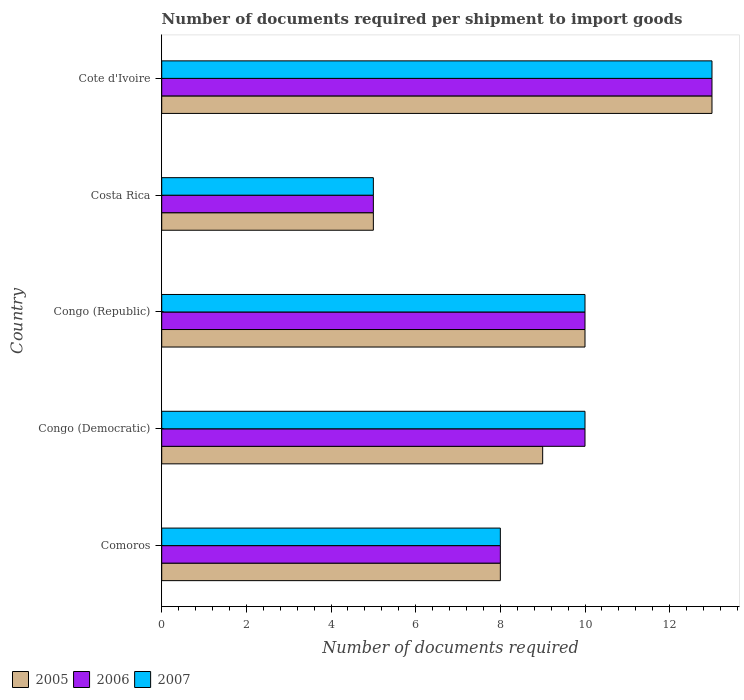How many different coloured bars are there?
Make the answer very short. 3. Are the number of bars on each tick of the Y-axis equal?
Make the answer very short. Yes. What is the label of the 4th group of bars from the top?
Give a very brief answer. Congo (Democratic). In how many cases, is the number of bars for a given country not equal to the number of legend labels?
Provide a short and direct response. 0. What is the number of documents required per shipment to import goods in 2006 in Costa Rica?
Ensure brevity in your answer.  5. Across all countries, what is the maximum number of documents required per shipment to import goods in 2006?
Your answer should be very brief. 13. In which country was the number of documents required per shipment to import goods in 2005 maximum?
Your answer should be very brief. Cote d'Ivoire. What is the total number of documents required per shipment to import goods in 2007 in the graph?
Give a very brief answer. 46. What is the difference between the number of documents required per shipment to import goods in 2006 in Comoros and the number of documents required per shipment to import goods in 2005 in Costa Rica?
Make the answer very short. 3. What is the difference between the number of documents required per shipment to import goods in 2005 and number of documents required per shipment to import goods in 2006 in Costa Rica?
Provide a short and direct response. 0. In how many countries, is the number of documents required per shipment to import goods in 2005 greater than 5.6 ?
Your answer should be very brief. 4. What is the ratio of the number of documents required per shipment to import goods in 2007 in Congo (Republic) to that in Cote d'Ivoire?
Your response must be concise. 0.77. Is the difference between the number of documents required per shipment to import goods in 2005 in Costa Rica and Cote d'Ivoire greater than the difference between the number of documents required per shipment to import goods in 2006 in Costa Rica and Cote d'Ivoire?
Keep it short and to the point. No. What is the difference between the highest and the second highest number of documents required per shipment to import goods in 2005?
Your answer should be compact. 3. What does the 1st bar from the top in Congo (Republic) represents?
Give a very brief answer. 2007. What does the 1st bar from the bottom in Congo (Republic) represents?
Keep it short and to the point. 2005. How many bars are there?
Offer a terse response. 15. Are all the bars in the graph horizontal?
Your answer should be very brief. Yes. How many countries are there in the graph?
Your answer should be compact. 5. What is the difference between two consecutive major ticks on the X-axis?
Offer a terse response. 2. Are the values on the major ticks of X-axis written in scientific E-notation?
Make the answer very short. No. Where does the legend appear in the graph?
Ensure brevity in your answer.  Bottom left. What is the title of the graph?
Ensure brevity in your answer.  Number of documents required per shipment to import goods. Does "2005" appear as one of the legend labels in the graph?
Your response must be concise. Yes. What is the label or title of the X-axis?
Provide a succinct answer. Number of documents required. What is the label or title of the Y-axis?
Provide a succinct answer. Country. What is the Number of documents required of 2006 in Comoros?
Your response must be concise. 8. What is the Number of documents required in 2005 in Congo (Democratic)?
Keep it short and to the point. 9. What is the Number of documents required in 2006 in Congo (Democratic)?
Make the answer very short. 10. What is the Number of documents required in 2005 in Congo (Republic)?
Make the answer very short. 10. What is the Number of documents required of 2006 in Congo (Republic)?
Provide a short and direct response. 10. What is the Number of documents required of 2005 in Costa Rica?
Offer a very short reply. 5. What is the Number of documents required of 2006 in Costa Rica?
Your response must be concise. 5. What is the Number of documents required in 2007 in Costa Rica?
Offer a very short reply. 5. Across all countries, what is the maximum Number of documents required in 2006?
Your response must be concise. 13. Across all countries, what is the maximum Number of documents required in 2007?
Your answer should be compact. 13. Across all countries, what is the minimum Number of documents required of 2005?
Your answer should be very brief. 5. Across all countries, what is the minimum Number of documents required of 2007?
Your response must be concise. 5. What is the total Number of documents required of 2005 in the graph?
Provide a short and direct response. 45. What is the total Number of documents required of 2006 in the graph?
Provide a short and direct response. 46. What is the difference between the Number of documents required in 2005 in Comoros and that in Congo (Democratic)?
Your answer should be very brief. -1. What is the difference between the Number of documents required in 2006 in Comoros and that in Congo (Democratic)?
Ensure brevity in your answer.  -2. What is the difference between the Number of documents required of 2007 in Comoros and that in Congo (Democratic)?
Your answer should be compact. -2. What is the difference between the Number of documents required of 2007 in Comoros and that in Congo (Republic)?
Offer a very short reply. -2. What is the difference between the Number of documents required in 2006 in Comoros and that in Costa Rica?
Ensure brevity in your answer.  3. What is the difference between the Number of documents required in 2007 in Comoros and that in Costa Rica?
Ensure brevity in your answer.  3. What is the difference between the Number of documents required of 2005 in Congo (Democratic) and that in Congo (Republic)?
Give a very brief answer. -1. What is the difference between the Number of documents required in 2006 in Congo (Democratic) and that in Congo (Republic)?
Provide a short and direct response. 0. What is the difference between the Number of documents required in 2007 in Congo (Democratic) and that in Costa Rica?
Offer a very short reply. 5. What is the difference between the Number of documents required in 2006 in Congo (Democratic) and that in Cote d'Ivoire?
Offer a terse response. -3. What is the difference between the Number of documents required in 2005 in Congo (Republic) and that in Cote d'Ivoire?
Keep it short and to the point. -3. What is the difference between the Number of documents required in 2006 in Costa Rica and that in Cote d'Ivoire?
Your answer should be very brief. -8. What is the difference between the Number of documents required of 2005 in Comoros and the Number of documents required of 2006 in Congo (Democratic)?
Your response must be concise. -2. What is the difference between the Number of documents required of 2006 in Comoros and the Number of documents required of 2007 in Congo (Democratic)?
Give a very brief answer. -2. What is the difference between the Number of documents required of 2005 in Comoros and the Number of documents required of 2007 in Congo (Republic)?
Make the answer very short. -2. What is the difference between the Number of documents required of 2006 in Comoros and the Number of documents required of 2007 in Congo (Republic)?
Give a very brief answer. -2. What is the difference between the Number of documents required of 2005 in Comoros and the Number of documents required of 2006 in Costa Rica?
Keep it short and to the point. 3. What is the difference between the Number of documents required of 2005 in Comoros and the Number of documents required of 2007 in Costa Rica?
Give a very brief answer. 3. What is the difference between the Number of documents required in 2006 in Comoros and the Number of documents required in 2007 in Costa Rica?
Give a very brief answer. 3. What is the difference between the Number of documents required in 2005 in Comoros and the Number of documents required in 2007 in Cote d'Ivoire?
Provide a short and direct response. -5. What is the difference between the Number of documents required of 2006 in Comoros and the Number of documents required of 2007 in Cote d'Ivoire?
Keep it short and to the point. -5. What is the difference between the Number of documents required of 2005 in Congo (Democratic) and the Number of documents required of 2006 in Congo (Republic)?
Provide a succinct answer. -1. What is the difference between the Number of documents required of 2005 in Congo (Democratic) and the Number of documents required of 2007 in Congo (Republic)?
Offer a very short reply. -1. What is the difference between the Number of documents required in 2006 in Congo (Democratic) and the Number of documents required in 2007 in Congo (Republic)?
Your answer should be compact. 0. What is the difference between the Number of documents required in 2005 in Congo (Democratic) and the Number of documents required in 2006 in Costa Rica?
Provide a short and direct response. 4. What is the difference between the Number of documents required in 2005 in Congo (Democratic) and the Number of documents required in 2007 in Costa Rica?
Give a very brief answer. 4. What is the difference between the Number of documents required of 2006 in Congo (Democratic) and the Number of documents required of 2007 in Cote d'Ivoire?
Provide a succinct answer. -3. What is the difference between the Number of documents required of 2005 in Congo (Republic) and the Number of documents required of 2006 in Costa Rica?
Your response must be concise. 5. What is the difference between the Number of documents required of 2005 in Congo (Republic) and the Number of documents required of 2007 in Costa Rica?
Offer a very short reply. 5. What is the difference between the Number of documents required of 2006 in Congo (Republic) and the Number of documents required of 2007 in Costa Rica?
Your response must be concise. 5. What is the difference between the Number of documents required of 2005 in Congo (Republic) and the Number of documents required of 2007 in Cote d'Ivoire?
Provide a succinct answer. -3. What is the difference between the Number of documents required of 2006 in Congo (Republic) and the Number of documents required of 2007 in Cote d'Ivoire?
Your answer should be very brief. -3. What is the difference between the Number of documents required in 2005 in Costa Rica and the Number of documents required in 2006 in Cote d'Ivoire?
Provide a short and direct response. -8. What is the difference between the Number of documents required in 2005 in Costa Rica and the Number of documents required in 2007 in Cote d'Ivoire?
Offer a terse response. -8. What is the difference between the Number of documents required in 2006 in Costa Rica and the Number of documents required in 2007 in Cote d'Ivoire?
Provide a short and direct response. -8. What is the average Number of documents required in 2005 per country?
Provide a short and direct response. 9. What is the average Number of documents required of 2006 per country?
Give a very brief answer. 9.2. What is the average Number of documents required in 2007 per country?
Offer a terse response. 9.2. What is the difference between the Number of documents required in 2006 and Number of documents required in 2007 in Comoros?
Your answer should be compact. 0. What is the difference between the Number of documents required of 2005 and Number of documents required of 2007 in Congo (Democratic)?
Provide a short and direct response. -1. What is the difference between the Number of documents required of 2006 and Number of documents required of 2007 in Congo (Republic)?
Offer a very short reply. 0. What is the difference between the Number of documents required of 2005 and Number of documents required of 2006 in Costa Rica?
Offer a very short reply. 0. What is the difference between the Number of documents required in 2005 and Number of documents required in 2007 in Costa Rica?
Your answer should be very brief. 0. What is the difference between the Number of documents required of 2006 and Number of documents required of 2007 in Costa Rica?
Your answer should be compact. 0. What is the ratio of the Number of documents required in 2005 in Comoros to that in Congo (Democratic)?
Provide a short and direct response. 0.89. What is the ratio of the Number of documents required in 2006 in Comoros to that in Congo (Democratic)?
Provide a succinct answer. 0.8. What is the ratio of the Number of documents required in 2007 in Comoros to that in Congo (Democratic)?
Make the answer very short. 0.8. What is the ratio of the Number of documents required of 2005 in Comoros to that in Congo (Republic)?
Provide a succinct answer. 0.8. What is the ratio of the Number of documents required in 2007 in Comoros to that in Costa Rica?
Your answer should be very brief. 1.6. What is the ratio of the Number of documents required of 2005 in Comoros to that in Cote d'Ivoire?
Ensure brevity in your answer.  0.62. What is the ratio of the Number of documents required of 2006 in Comoros to that in Cote d'Ivoire?
Your response must be concise. 0.62. What is the ratio of the Number of documents required of 2007 in Comoros to that in Cote d'Ivoire?
Your answer should be very brief. 0.62. What is the ratio of the Number of documents required of 2005 in Congo (Democratic) to that in Costa Rica?
Give a very brief answer. 1.8. What is the ratio of the Number of documents required in 2007 in Congo (Democratic) to that in Costa Rica?
Ensure brevity in your answer.  2. What is the ratio of the Number of documents required in 2005 in Congo (Democratic) to that in Cote d'Ivoire?
Give a very brief answer. 0.69. What is the ratio of the Number of documents required in 2006 in Congo (Democratic) to that in Cote d'Ivoire?
Your answer should be very brief. 0.77. What is the ratio of the Number of documents required of 2007 in Congo (Democratic) to that in Cote d'Ivoire?
Provide a short and direct response. 0.77. What is the ratio of the Number of documents required in 2005 in Congo (Republic) to that in Costa Rica?
Keep it short and to the point. 2. What is the ratio of the Number of documents required in 2007 in Congo (Republic) to that in Costa Rica?
Offer a very short reply. 2. What is the ratio of the Number of documents required in 2005 in Congo (Republic) to that in Cote d'Ivoire?
Your answer should be compact. 0.77. What is the ratio of the Number of documents required in 2006 in Congo (Republic) to that in Cote d'Ivoire?
Your answer should be compact. 0.77. What is the ratio of the Number of documents required in 2007 in Congo (Republic) to that in Cote d'Ivoire?
Offer a terse response. 0.77. What is the ratio of the Number of documents required of 2005 in Costa Rica to that in Cote d'Ivoire?
Provide a succinct answer. 0.38. What is the ratio of the Number of documents required in 2006 in Costa Rica to that in Cote d'Ivoire?
Your answer should be compact. 0.38. What is the ratio of the Number of documents required of 2007 in Costa Rica to that in Cote d'Ivoire?
Offer a very short reply. 0.38. What is the difference between the highest and the second highest Number of documents required in 2005?
Your answer should be compact. 3. What is the difference between the highest and the second highest Number of documents required in 2006?
Your response must be concise. 3. What is the difference between the highest and the lowest Number of documents required of 2007?
Offer a very short reply. 8. 